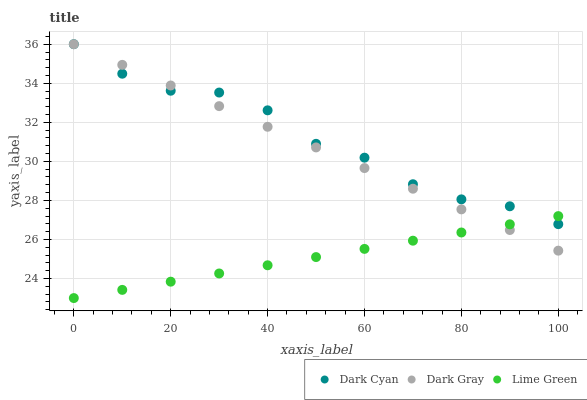Does Lime Green have the minimum area under the curve?
Answer yes or no. Yes. Does Dark Cyan have the maximum area under the curve?
Answer yes or no. Yes. Does Dark Gray have the minimum area under the curve?
Answer yes or no. No. Does Dark Gray have the maximum area under the curve?
Answer yes or no. No. Is Lime Green the smoothest?
Answer yes or no. Yes. Is Dark Cyan the roughest?
Answer yes or no. Yes. Is Dark Gray the smoothest?
Answer yes or no. No. Is Dark Gray the roughest?
Answer yes or no. No. Does Lime Green have the lowest value?
Answer yes or no. Yes. Does Dark Gray have the lowest value?
Answer yes or no. No. Does Dark Gray have the highest value?
Answer yes or no. Yes. Does Lime Green have the highest value?
Answer yes or no. No. Does Dark Gray intersect Lime Green?
Answer yes or no. Yes. Is Dark Gray less than Lime Green?
Answer yes or no. No. Is Dark Gray greater than Lime Green?
Answer yes or no. No. 